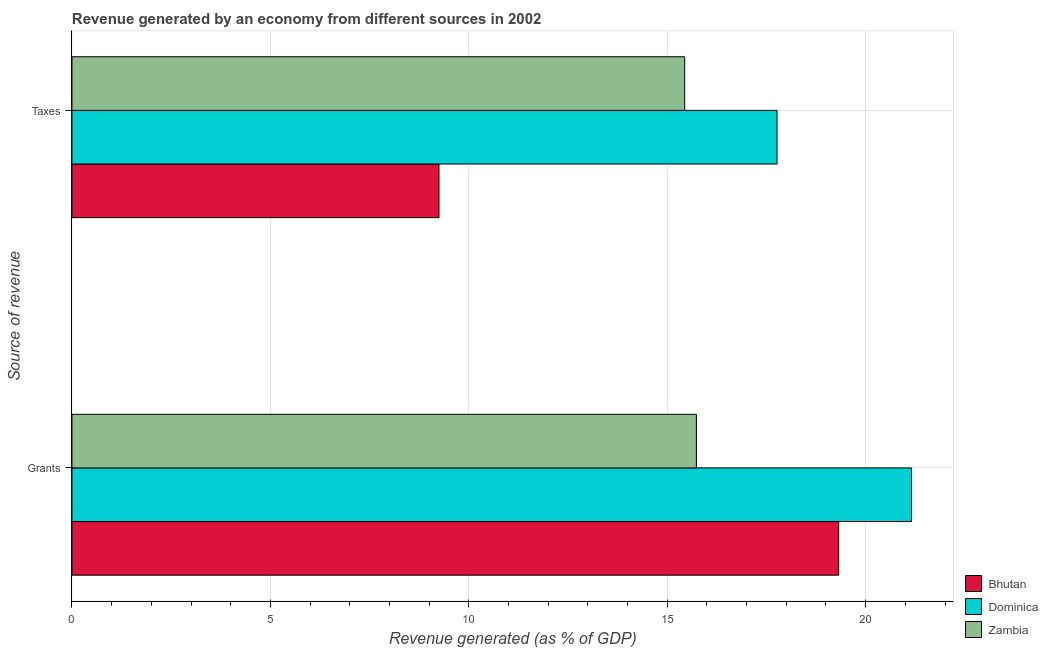How many groups of bars are there?
Offer a very short reply. 2. Are the number of bars per tick equal to the number of legend labels?
Your answer should be compact. Yes. How many bars are there on the 1st tick from the top?
Offer a terse response. 3. What is the label of the 1st group of bars from the top?
Offer a very short reply. Taxes. What is the revenue generated by taxes in Bhutan?
Offer a very short reply. 9.25. Across all countries, what is the maximum revenue generated by grants?
Keep it short and to the point. 21.16. Across all countries, what is the minimum revenue generated by grants?
Provide a succinct answer. 15.74. In which country was the revenue generated by grants maximum?
Keep it short and to the point. Dominica. In which country was the revenue generated by taxes minimum?
Your answer should be compact. Bhutan. What is the total revenue generated by taxes in the graph?
Your response must be concise. 42.46. What is the difference between the revenue generated by taxes in Zambia and that in Bhutan?
Your answer should be very brief. 6.19. What is the difference between the revenue generated by taxes in Dominica and the revenue generated by grants in Bhutan?
Offer a terse response. -1.55. What is the average revenue generated by taxes per country?
Offer a very short reply. 14.15. What is the difference between the revenue generated by taxes and revenue generated by grants in Bhutan?
Your answer should be very brief. -10.07. What is the ratio of the revenue generated by taxes in Zambia to that in Dominica?
Your response must be concise. 0.87. Is the revenue generated by taxes in Bhutan less than that in Dominica?
Provide a succinct answer. Yes. In how many countries, is the revenue generated by grants greater than the average revenue generated by grants taken over all countries?
Your response must be concise. 2. What does the 2nd bar from the top in Grants represents?
Make the answer very short. Dominica. What does the 2nd bar from the bottom in Grants represents?
Offer a very short reply. Dominica. How many bars are there?
Your response must be concise. 6. Are all the bars in the graph horizontal?
Give a very brief answer. Yes. How many countries are there in the graph?
Give a very brief answer. 3. What is the difference between two consecutive major ticks on the X-axis?
Provide a succinct answer. 5. Are the values on the major ticks of X-axis written in scientific E-notation?
Provide a succinct answer. No. Does the graph contain any zero values?
Give a very brief answer. No. What is the title of the graph?
Make the answer very short. Revenue generated by an economy from different sources in 2002. What is the label or title of the X-axis?
Provide a succinct answer. Revenue generated (as % of GDP). What is the label or title of the Y-axis?
Your answer should be compact. Source of revenue. What is the Revenue generated (as % of GDP) of Bhutan in Grants?
Your answer should be compact. 19.32. What is the Revenue generated (as % of GDP) of Dominica in Grants?
Your response must be concise. 21.16. What is the Revenue generated (as % of GDP) of Zambia in Grants?
Ensure brevity in your answer.  15.74. What is the Revenue generated (as % of GDP) in Bhutan in Taxes?
Provide a succinct answer. 9.25. What is the Revenue generated (as % of GDP) of Dominica in Taxes?
Make the answer very short. 17.77. What is the Revenue generated (as % of GDP) of Zambia in Taxes?
Offer a very short reply. 15.44. Across all Source of revenue, what is the maximum Revenue generated (as % of GDP) in Bhutan?
Provide a succinct answer. 19.32. Across all Source of revenue, what is the maximum Revenue generated (as % of GDP) of Dominica?
Offer a very short reply. 21.16. Across all Source of revenue, what is the maximum Revenue generated (as % of GDP) of Zambia?
Your answer should be compact. 15.74. Across all Source of revenue, what is the minimum Revenue generated (as % of GDP) of Bhutan?
Offer a terse response. 9.25. Across all Source of revenue, what is the minimum Revenue generated (as % of GDP) in Dominica?
Provide a succinct answer. 17.77. Across all Source of revenue, what is the minimum Revenue generated (as % of GDP) in Zambia?
Provide a succinct answer. 15.44. What is the total Revenue generated (as % of GDP) in Bhutan in the graph?
Give a very brief answer. 28.57. What is the total Revenue generated (as % of GDP) of Dominica in the graph?
Give a very brief answer. 38.92. What is the total Revenue generated (as % of GDP) in Zambia in the graph?
Give a very brief answer. 31.18. What is the difference between the Revenue generated (as % of GDP) of Bhutan in Grants and that in Taxes?
Offer a very short reply. 10.07. What is the difference between the Revenue generated (as % of GDP) of Dominica in Grants and that in Taxes?
Offer a terse response. 3.39. What is the difference between the Revenue generated (as % of GDP) in Zambia in Grants and that in Taxes?
Make the answer very short. 0.3. What is the difference between the Revenue generated (as % of GDP) of Bhutan in Grants and the Revenue generated (as % of GDP) of Dominica in Taxes?
Provide a succinct answer. 1.55. What is the difference between the Revenue generated (as % of GDP) in Bhutan in Grants and the Revenue generated (as % of GDP) in Zambia in Taxes?
Offer a terse response. 3.88. What is the difference between the Revenue generated (as % of GDP) of Dominica in Grants and the Revenue generated (as % of GDP) of Zambia in Taxes?
Keep it short and to the point. 5.72. What is the average Revenue generated (as % of GDP) in Bhutan per Source of revenue?
Ensure brevity in your answer.  14.28. What is the average Revenue generated (as % of GDP) of Dominica per Source of revenue?
Provide a short and direct response. 19.46. What is the average Revenue generated (as % of GDP) in Zambia per Source of revenue?
Make the answer very short. 15.59. What is the difference between the Revenue generated (as % of GDP) of Bhutan and Revenue generated (as % of GDP) of Dominica in Grants?
Keep it short and to the point. -1.84. What is the difference between the Revenue generated (as % of GDP) in Bhutan and Revenue generated (as % of GDP) in Zambia in Grants?
Give a very brief answer. 3.58. What is the difference between the Revenue generated (as % of GDP) in Dominica and Revenue generated (as % of GDP) in Zambia in Grants?
Offer a terse response. 5.42. What is the difference between the Revenue generated (as % of GDP) of Bhutan and Revenue generated (as % of GDP) of Dominica in Taxes?
Offer a terse response. -8.52. What is the difference between the Revenue generated (as % of GDP) in Bhutan and Revenue generated (as % of GDP) in Zambia in Taxes?
Keep it short and to the point. -6.19. What is the difference between the Revenue generated (as % of GDP) of Dominica and Revenue generated (as % of GDP) of Zambia in Taxes?
Provide a succinct answer. 2.33. What is the ratio of the Revenue generated (as % of GDP) of Bhutan in Grants to that in Taxes?
Offer a terse response. 2.09. What is the ratio of the Revenue generated (as % of GDP) in Dominica in Grants to that in Taxes?
Offer a very short reply. 1.19. What is the ratio of the Revenue generated (as % of GDP) in Zambia in Grants to that in Taxes?
Offer a terse response. 1.02. What is the difference between the highest and the second highest Revenue generated (as % of GDP) of Bhutan?
Your answer should be very brief. 10.07. What is the difference between the highest and the second highest Revenue generated (as % of GDP) of Dominica?
Your response must be concise. 3.39. What is the difference between the highest and the second highest Revenue generated (as % of GDP) of Zambia?
Your answer should be very brief. 0.3. What is the difference between the highest and the lowest Revenue generated (as % of GDP) of Bhutan?
Your response must be concise. 10.07. What is the difference between the highest and the lowest Revenue generated (as % of GDP) in Dominica?
Offer a very short reply. 3.39. What is the difference between the highest and the lowest Revenue generated (as % of GDP) in Zambia?
Provide a succinct answer. 0.3. 